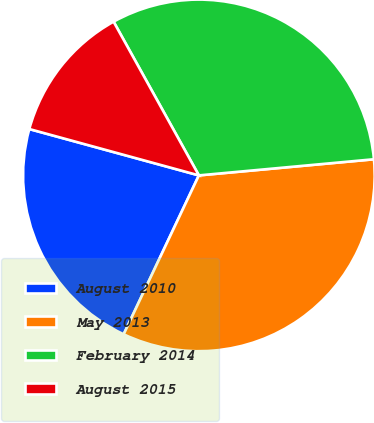<chart> <loc_0><loc_0><loc_500><loc_500><pie_chart><fcel>August 2010<fcel>May 2013<fcel>February 2014<fcel>August 2015<nl><fcel>22.21%<fcel>33.5%<fcel>31.6%<fcel>12.69%<nl></chart> 